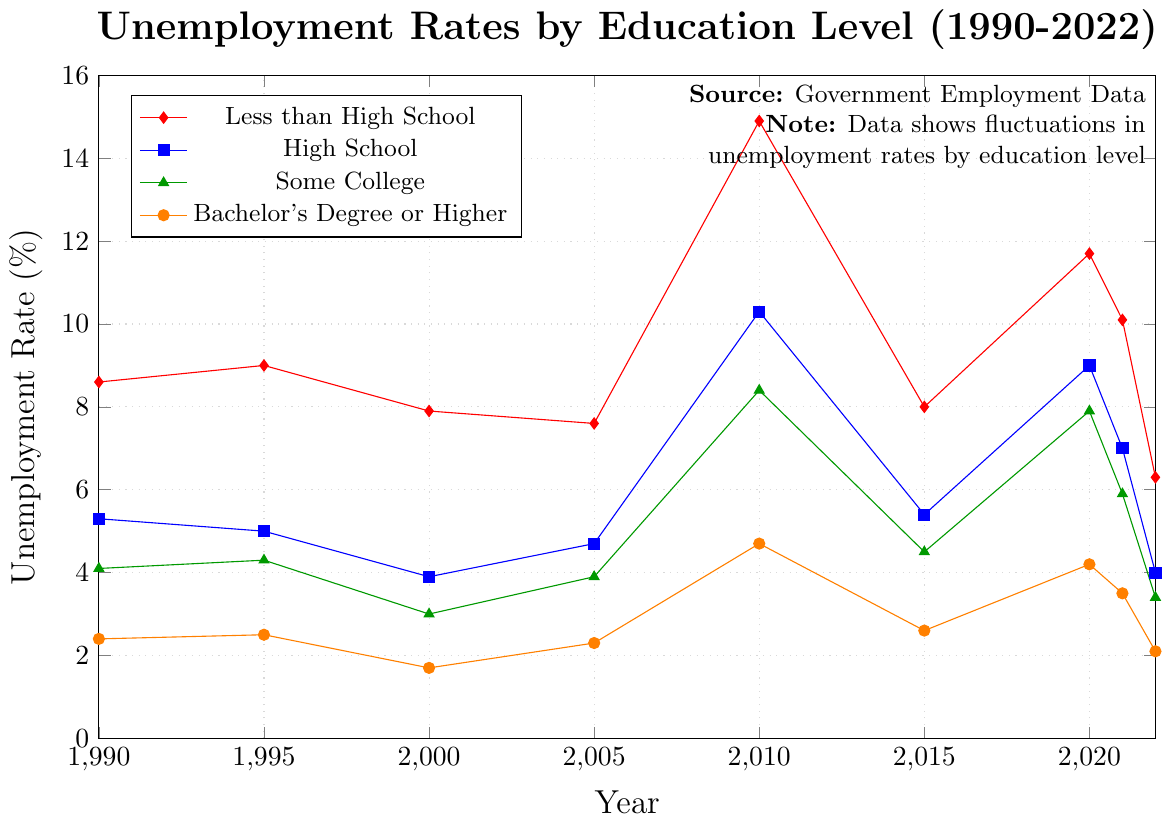Which education level had the highest unemployment rate in 2010? The highest point on the vertical axis is at around 14.9% for the "Less than High School" group.
Answer: Less than High School Between 1990 and 2022, which year had the lowest unemployment rate for those with a Bachelor's Degree or Higher? By tracing the line for "Bachelor's Degree or Higher," the lowest point is at 1.7% in the year 2000.
Answer: 2000 What was the difference in unemployment rates between those with "Some College" and "High School" education in 2022? In 2022, the unemployment rate for "Some College" was 3.4%, and for "High School," it was 4.0%. The difference is 4.0% - 3.4% = 0.6%.
Answer: 0.6% Which education level experienced the largest increase in unemployment rate from 2000 to 2010? Observing the slopes of the lines between 2000 and 2010, "Less than High School" increased from 7.9% to 14.9%, which is the largest increase of 7.0%.
Answer: Less than High School In which year did those with "High School" education have an unemployment rate of over 9%? By following the "High School" line, it surpasses 9% specifically in 2010, reaching 10.3%.
Answer: 2010 What was the average unemployment rate for individuals with "Less than High School" education across the years provided? The unemployment rates are: 8.6, 9.0, 7.9, 7.6, 14.9, 8.0, 11.7, 10.1, 6.3. Summing them up gives 84.1. Dividing by 9 (the number of data points) gives 84.1 / 9 ≈ 9.34%.
Answer: 9.34% Which education level had the least fluctuations in unemployment rate over the years? By looking at the visual oscillations, "Bachelor's Degree or Higher" shows the most stable trend with the least dramatic changes in rates.
Answer: Bachelor's Degree or Higher How much did the unemployment rate for "High School" education change from 1990 to 2022? In 1990, the rate was 5.3%, and in 2022, it was 4.0%. The change is 5.3% - 4.0% = 1.3%.
Answer: 1.3% What is the peak unemployment rate observed for the "Some College" education level? By following the highest point in the "Some College" line, the peak rate occurs at 8.4% in 2010.
Answer: 8.4% How did the unemployment rate trend for those with "Less than High School" education compare to those with a "Bachelor's Degree or Higher" from 1990 to 2022? Over the years, "Less than High School" consistently had higher unemployment rates compared to the "Bachelor's Degree or Higher" group, with a notable peak at 14.9% in 2010 compared to 4.7% for the latter.
Answer: Less than High School rates higher 